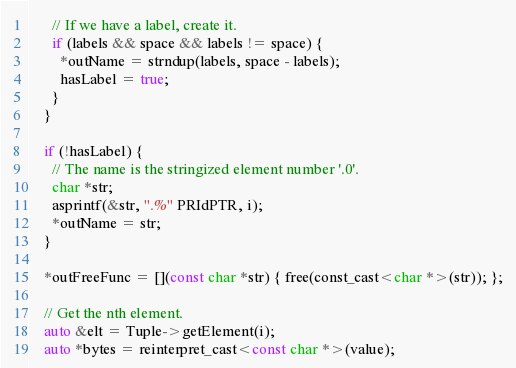<code> <loc_0><loc_0><loc_500><loc_500><_ObjectiveC_>      // If we have a label, create it.
      if (labels && space && labels != space) {
        *outName = strndup(labels, space - labels);
        hasLabel = true;
      }
    }

    if (!hasLabel) {
      // The name is the stringized element number '.0'.
      char *str;
      asprintf(&str, ".%" PRIdPTR, i);
      *outName = str;
    }

    *outFreeFunc = [](const char *str) { free(const_cast<char *>(str)); };

    // Get the nth element.
    auto &elt = Tuple->getElement(i);
    auto *bytes = reinterpret_cast<const char *>(value);</code> 